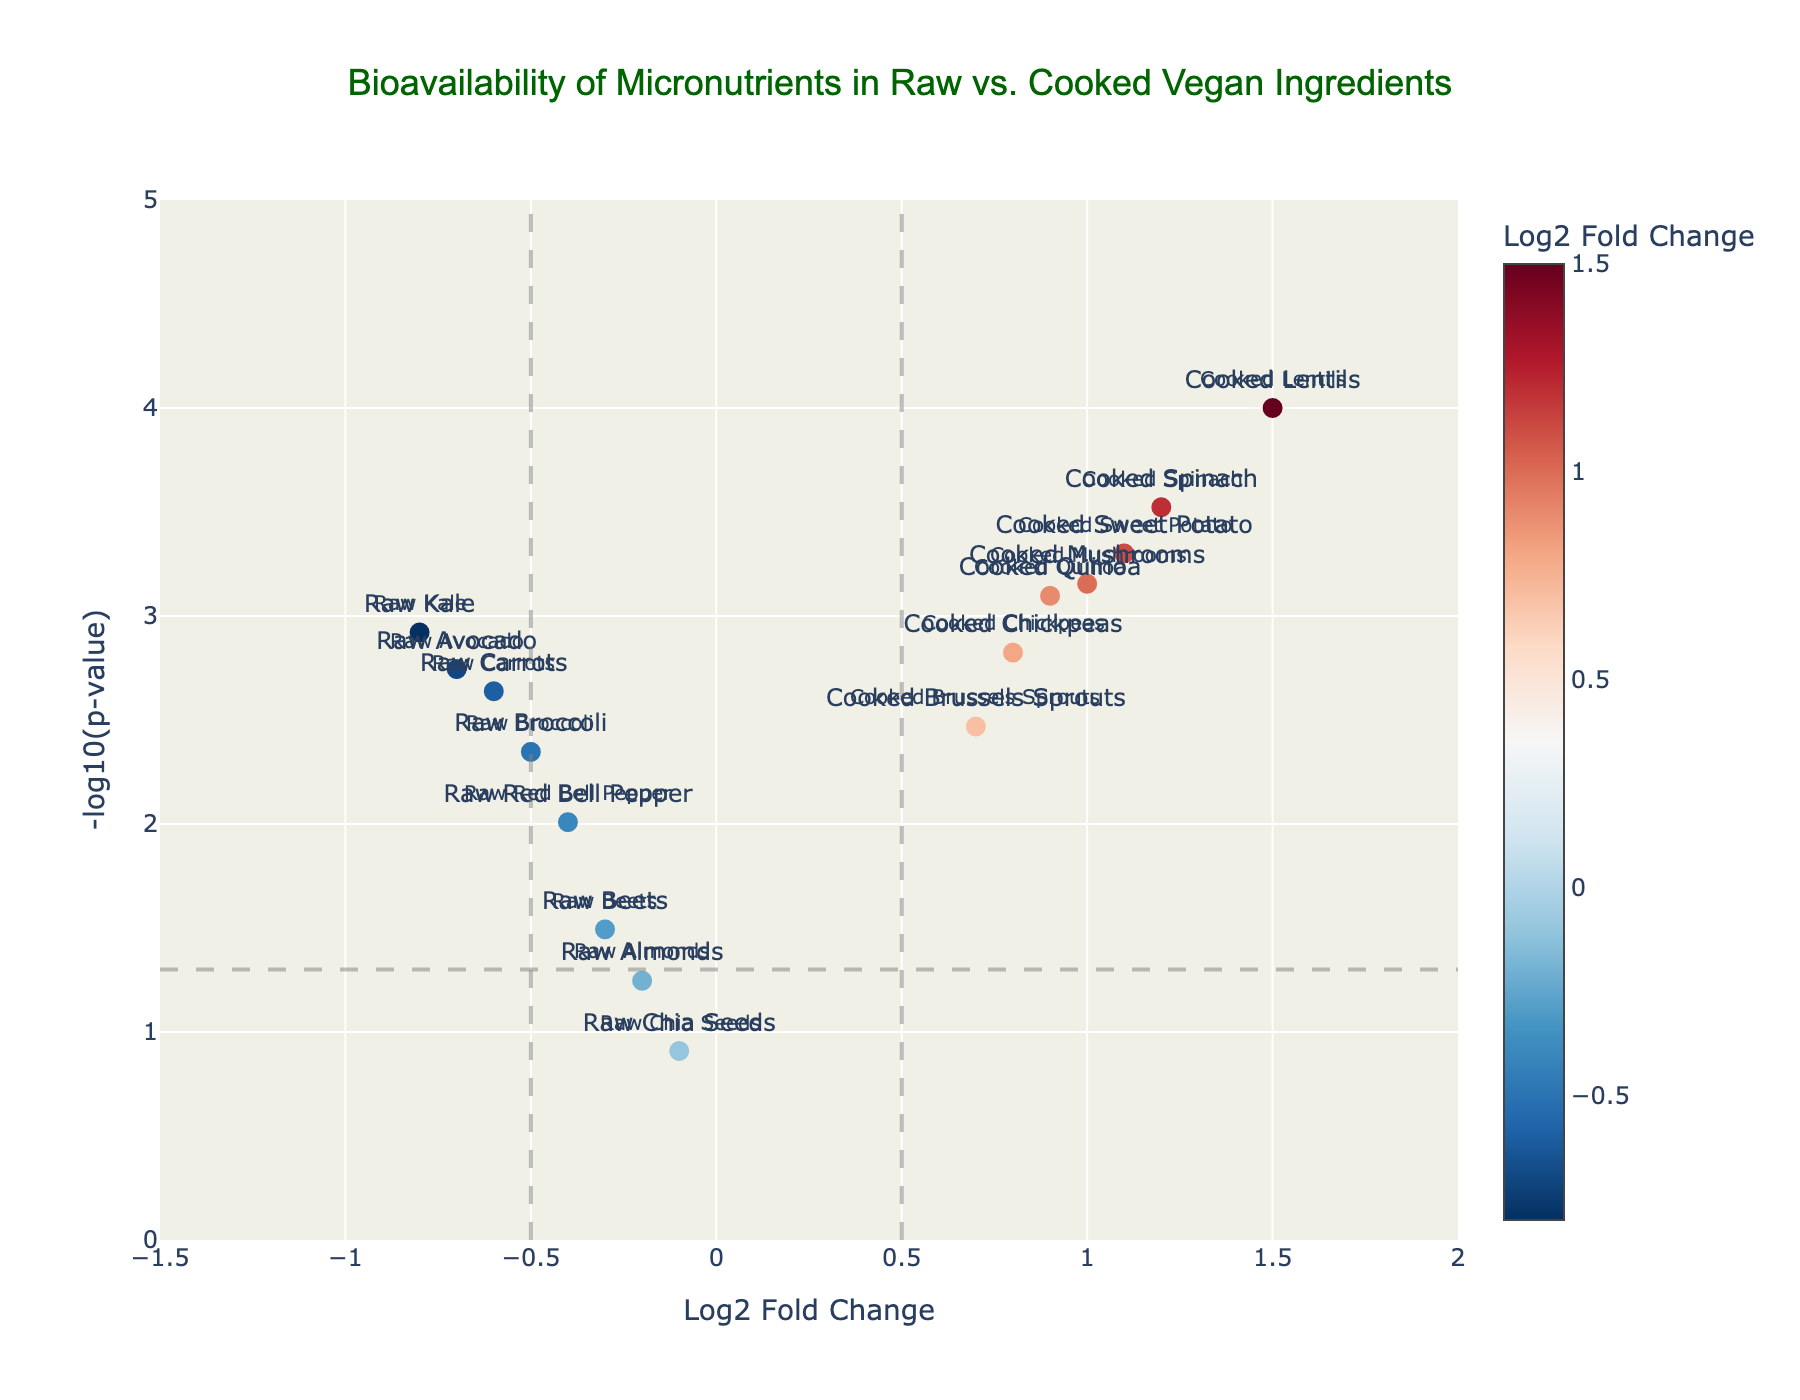What is the title of the plot? The title is typically positioned at the top and contains a summary description of the plot. In this plot, the title is "Bioavailability of Micronutrients in Raw vs. Cooked Vegan Ingredients".
Answer: Bioavailability of Micronutrients in Raw vs. Cooked Vegan Ingredients How many ingredients are analyzed in this plot? The number of data points corresponds to the number of ingredients listed. Counting the data points or the rows in the table gives us a total of 15 ingredients.
Answer: 15 Which ingredient has the highest -log10(p-value)? We find the highest point on the y-axis since the y-axis represents -log10(p-value). Cooked Lentils have the highest -log10(p-value), indicating the lowest p-value.
Answer: Cooked Lentils Which ingredient has the lowest Log2 Fold Change? The lowest Log2 Fold Change is the point farthest to the left on the x-axis. Raw Kale has a Log2 Fold Change of -0.8, the lowest in the plot.
Answer: Raw Kale What is the p-value threshold line set at? The threshold lines for significance often represent a p-value of 0.05. This corresponds to a -log10(p-value) of -log10(0.05) = 1.3, as indicated by one of the horizontal lines in the plot.
Answer: 0.05 How many ingredients fall above the significance threshold line (p < 0.05)? Any data point above the horizontal line at -log10(p-value) of 1.3 is considered statistically significant. Counts show that 11 ingredients are above this line.
Answer: 11 Which cooked ingredient has the lowest Log2 Fold Change? Locate the points labeled for cooked ingredients and find the smallest value on the x-axis. Cooked Brussels Sprouts has the lowest at 0.7.
Answer: Cooked Brussels Sprouts Which ingredient(s) have a Log2 Fold Change value between -0.5 and 0.5? Check the x-axis range between -0.5 and 0.5 and identify corresponding points. Raw Broccoli (-0.5), Raw Beets (-0.3), Raw Almonds (-0.2), and Raw Chia Seeds (-0.1) fall within this range.
Answer: Raw Broccoli, Raw Beets, Raw Almonds, Raw Chia Seeds Compare the bioavailability of micronutrients in Cooked Spinach and Cooked Lentils. Which one is higher and by how much? Look at the Log2 Fold Change values. Cooked Spinach has a value of 1.2 while Cooked Lentils has 1.5. The difference is 1.5 - 1.2 = 0.3.
Answer: Cooked Lentils by 0.3 Are any raw ingredients significantly more bioavailable compared to their cooked counterparts? Significant bioavailability is indicated by points far from zero on the x-axis past the threshold. None of the raw ingredients have positive Log2 Fold Change values, thus none are significantly more bioavailable.
Answer: No 